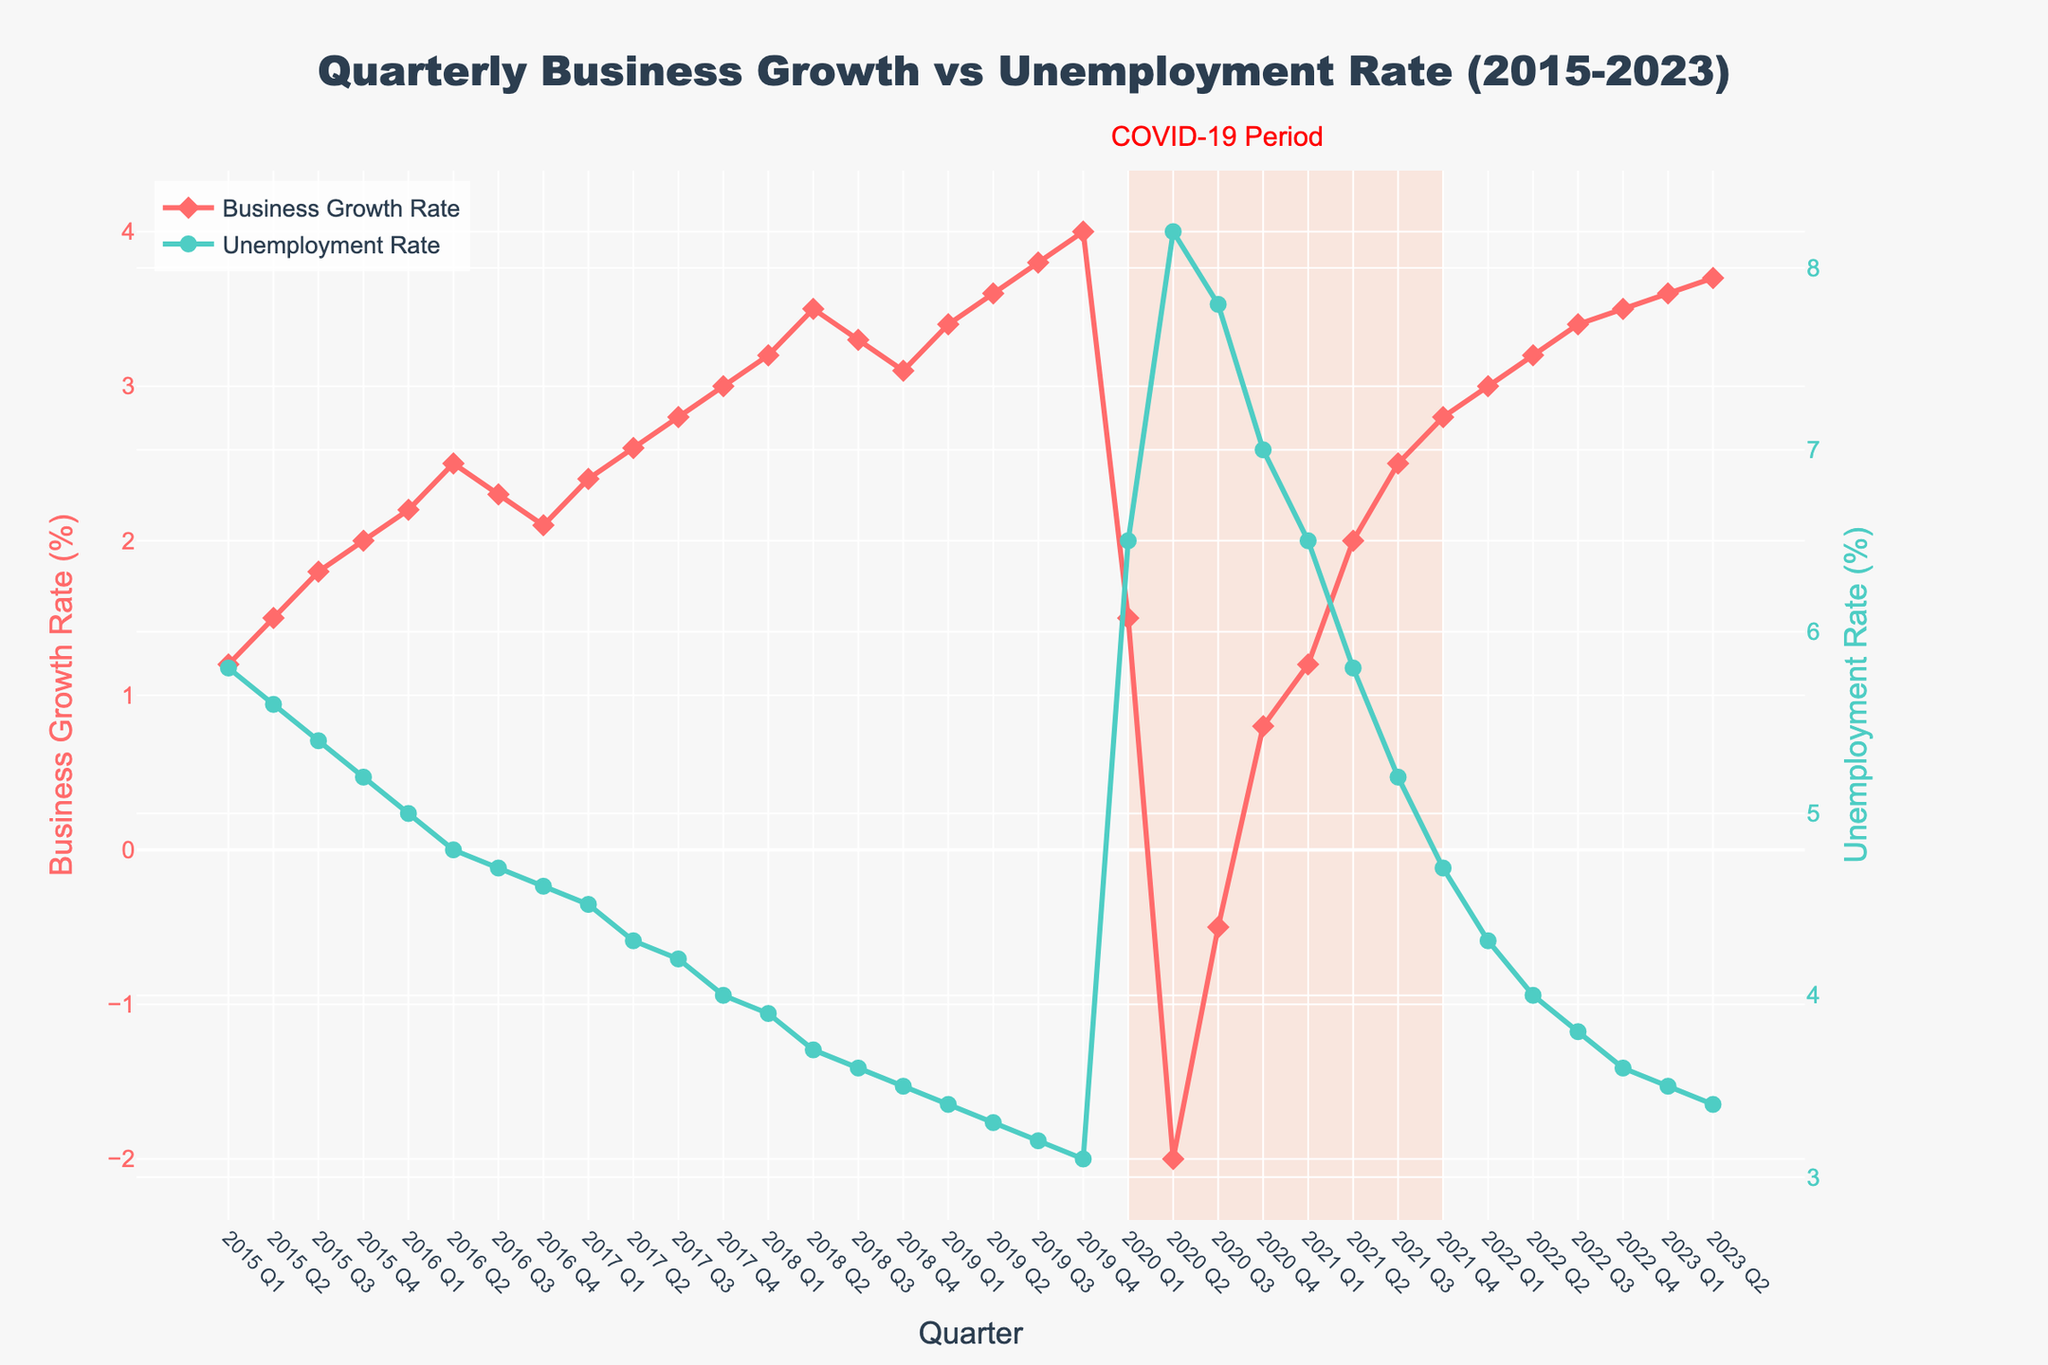What was the Business Growth Rate in 2016 Q2? The figure shows the Business Growth Rate by quarters. For the quarter labeled 2016 Q2, locate the corresponding value on the y-axis for Business Growth Rate (displayed in red).
Answer: 2.5 How does the Unemployment Rate in 2020 Q2 compare to the Business Growth Rate in the same period? First, find and note the values of both the Unemployment Rate (green line) and Business Growth Rate (red line) for 2020 Q2. Compare these two values. The Unemployment Rate was higher and negative growth was noted in Business Growth Rate.
Answer: Unemployment Rate: 8.2, Business Growth Rate: -2.0 What is the overall trend in Business Growth Rate and Unemployment Rate from 2015 to 2023 Q2? Observe the overall pattern of the red (Business Growth Rate) and green (Unemployment Rate) lines from 2015 to 2023 Q2. Initially, the Business Growth Rate increases while the Unemployment Rate decreases. Then there's a significant disruption during the COVID-19 period (2020 Q1 to 2021 Q4). Post-COVID-19, Business Growth rebounded, and Unemployment Rate dropped again.
Answer: Business Growth Rate: Increasing, Unemployment Rate: Decreasing By how much did the Business Growth Rate change between 2020 Q1 and 2020 Q2? Look for the Business Growth Rate values for both 2020 Q1 and 2020 Q2. Calculate the difference between these two values to find the change. The rate drops from 1.5% to -2.0%.
Answer: -3.5% During the COVID-19 period (2020 Q1 to 2021 Q4), what was the lowest Unemployment Rate recorded? Identify the lowest point of the green line (Unemployment Rate) within the shaded rectangular region indicating the COVID-19 period from the annotation "COVID-19 Period." The lowest value within this period is 4.7% in 2021 Q4.
Answer: 4.7% Which quarter had the highest Business Growth Rate since 2015? To find the highest point on the red line (Business Growth Rate), scan through all the peaks from 2015 to 2023. The highest peak is at 4.0% in 2019 Q4.
Answer: 2019 Q4 What is the total change in the Unemployment Rate from 2015 Q1 to 2023 Q2? Subtract the initial Unemployment Rate value in 2015 Q1 (5.8%) from the final value in 2023 Q2 (3.4%).
Answer: -2.4% In which year did we observe the maximum drop in Business Growth Rate compared to the previous year? Identify the year with the steepest downward slope in the red line. From 2019 Q4 to 2020 Q2, there was a sharp decline, marking the year with the most significant drop.
Answer: 2020 How many quarters had a negative Business Growth Rate, and during which periods did they occur? Scan the red line and count the quarters where the Business Growth Rate dips below 0. Identify these periods. Negative growth occurred in 2020 Q2 and Q3.
Answer: 2 quarters: 2020 Q2 and Q3 Compare the Unemployment Rate in 2019 Q4 with that in 2021 Q4. Has it increased or decreased? Locate 2019 Q4 and 2021 Q4 on the x-axis, and note the Unemployment Rates for these quarters (3.1% and 4.7% respectively). Compare these values to determine the change.
Answer: Increased 